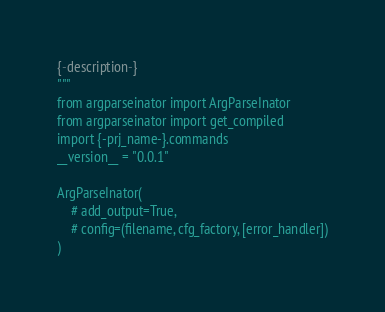<code> <loc_0><loc_0><loc_500><loc_500><_Python_>
{-description-}
"""
from argparseinator import ArgParseInator
from argparseinator import get_compiled
import {-prj_name-}.commands
__version__ = "0.0.1"

ArgParseInator(
    # add_output=True,
    # config=(filename, cfg_factory, [error_handler])
)
</code> 